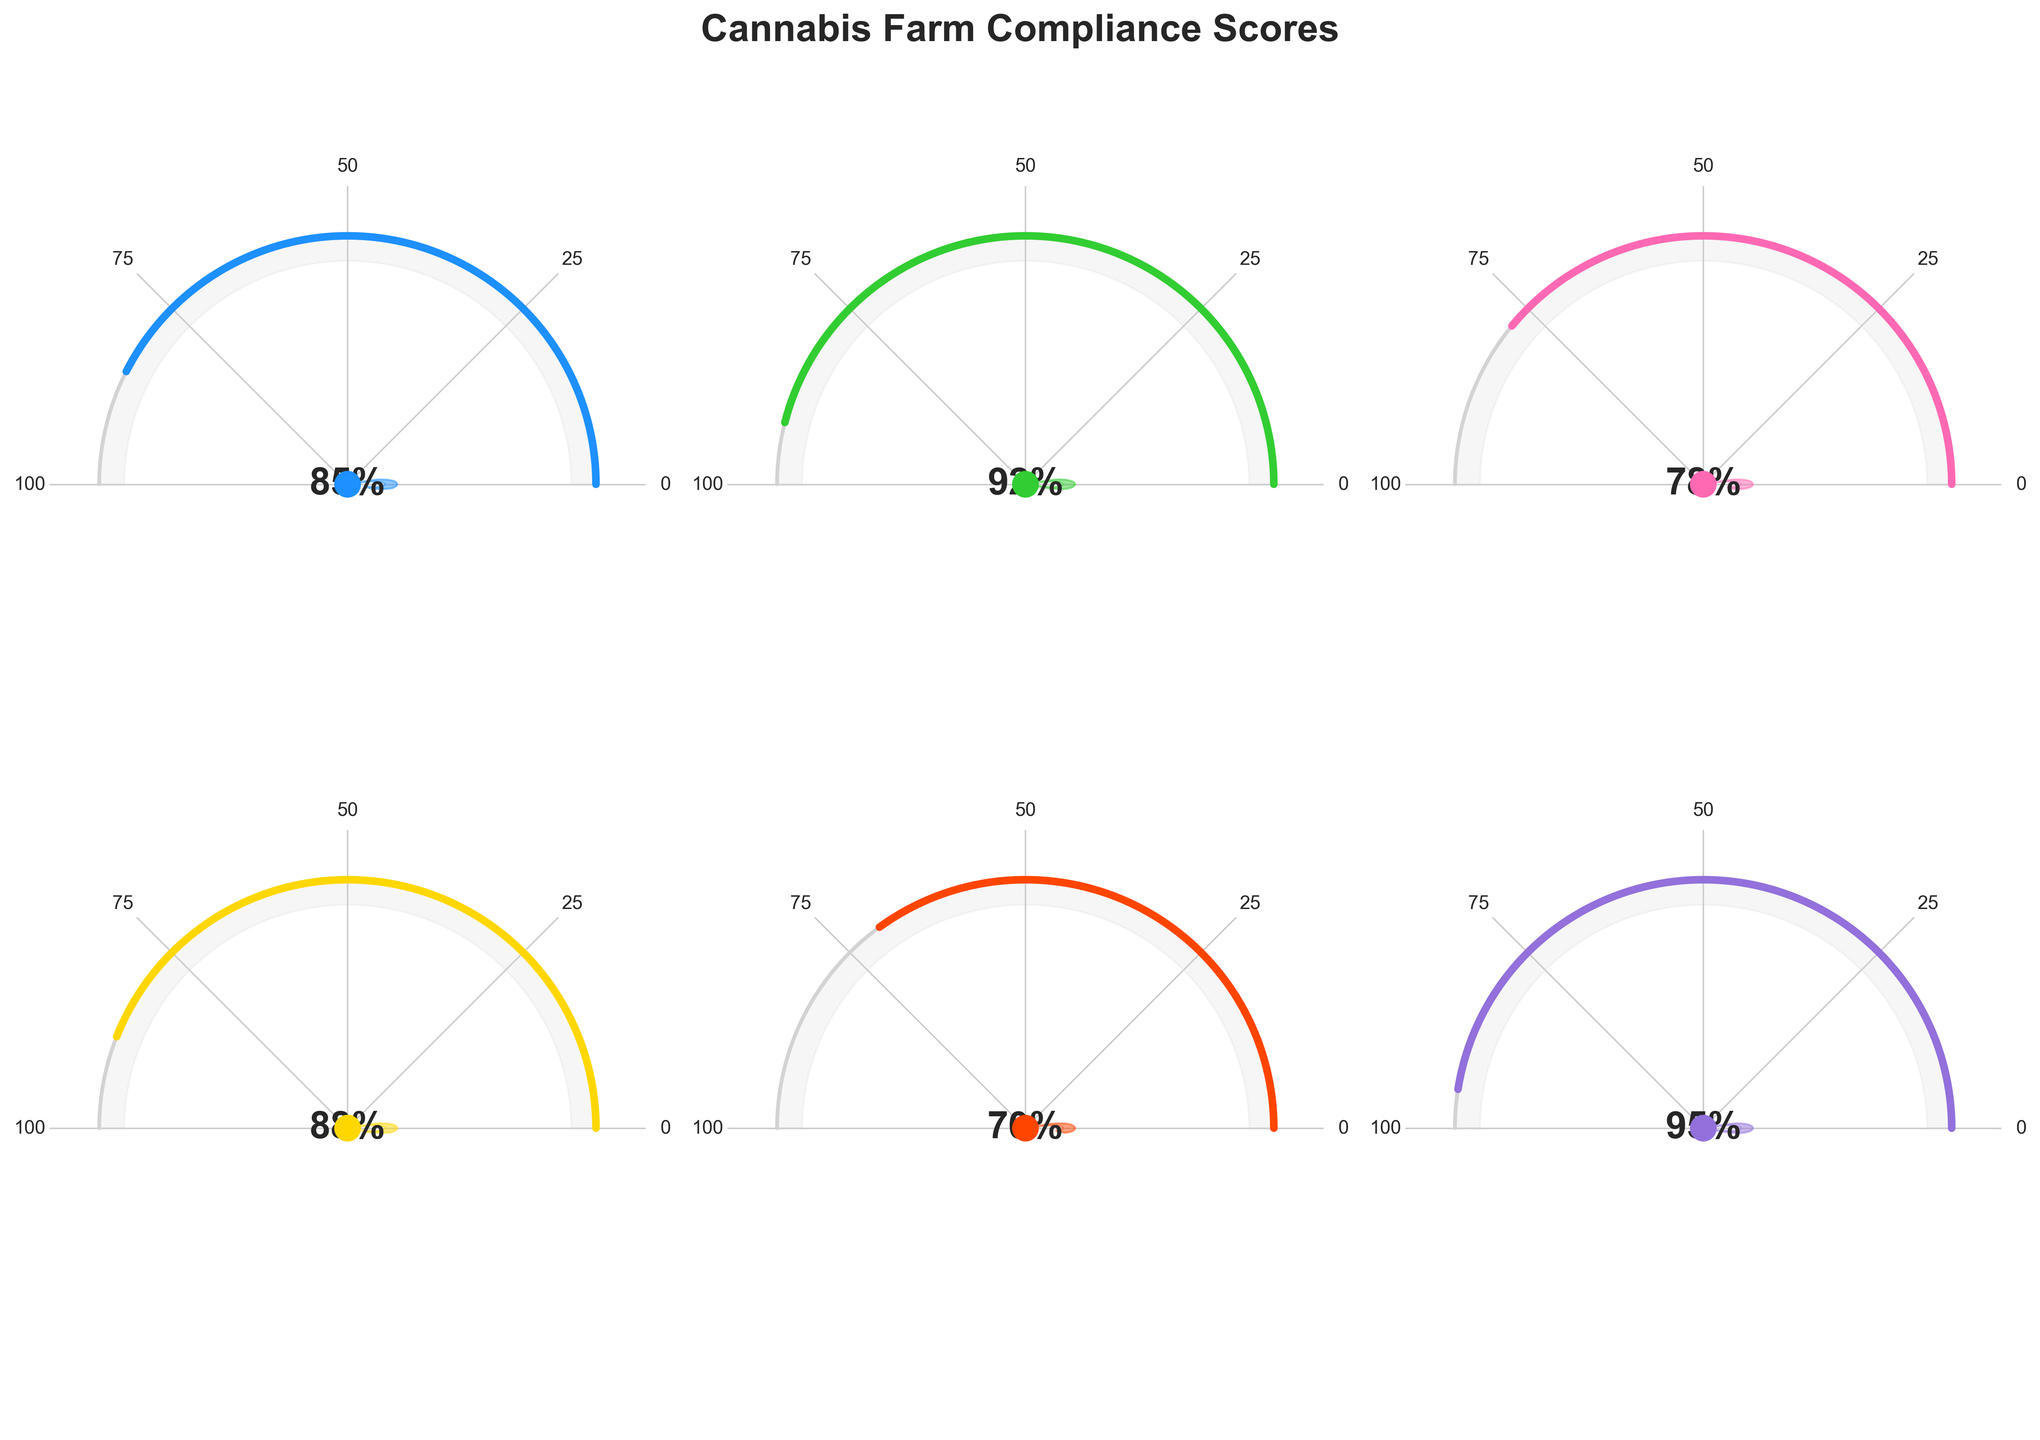What is the title of the figure? The title of the figure is positioned at the top and reads "Cannabis Farm Compliance Scores".
Answer: Cannabis Farm Compliance Scores Which category has the highest compliance score? By looking at the score displayed inside the gauge charts, the "Packaging & Labeling" category has the highest score with 95%.
Answer: Packaging & Labeling What is the compliance score for "Product Testing"? By referring to the gauge chart for "Product Testing", the score is displayed as 70%.
Answer: 70% How many compliance categories have a score above 80? There are six categories. By checking the score for each, five categories have scores above 80: Overall Compliance (85%), Security Measures (92%), Cultivation Practices (78%, below 80), Record Keeping (88%), Product Testing (70%, below 80), and Packaging & Labeling (95%).
Answer: 4 Which compliance score is the lowest, and what is that score? The lowest score can be identified by examining each gauge chart for their respective scores. "Product Testing" has the lowest score at 70%.
Answer: Product Testing, 70% Are there any categories with scores between 75 and 85? By looking at each gauge chart, "Cultivation Practices" has a score of 78% which falls in the specified range.
Answer: Yes, Cultivation Practices (78%) What is the average compliance score of all categories? Sum the scores: 85 (Overall Compliance) + 92 (Security Measures) + 78 (Cultivation Practices) + 88 (Record Keeping) + 70 (Product Testing) + 95 (Packaging & Labeling) = 508. Divide by the number of categories: 508 / 6 = 84.67.
Answer: 84.67 Which two categories have the closest compliance scores, and what are those scores? By comparing each score, "Overall Compliance" (85%) and "Record Keeping" (88%) have the closest scores with a difference of 3%.
Answer: Overall Compliance (85%) and Record Keeping (88%) How does the compliance score for "Security Measures" compare to "Cultivation Practices"? "Security Measures" has a higher compliance score (92%) compared to "Cultivation Practices" (78%).
Answer: Security Measures (92%) > Cultivation Practices (78%) List the categories in descending order of their compliance scores. By arranging the scores from highest to lowest: Packaging & Labeling (95%), Security Measures (92%), Record Keeping (88%), Overall Compliance (85%), Cultivation Practices (78%), Product Testing (70%).
Answer: Packaging & Labeling, Security Measures, Record Keeping, Overall Compliance, Cultivation Practices, Product Testing 